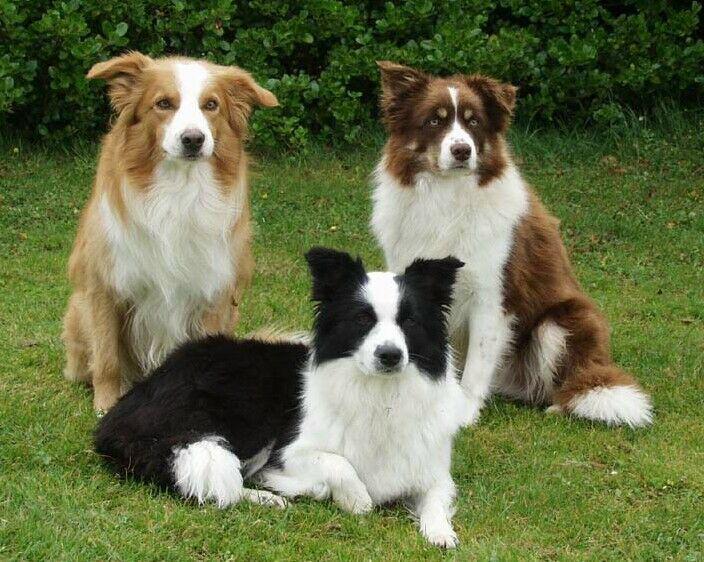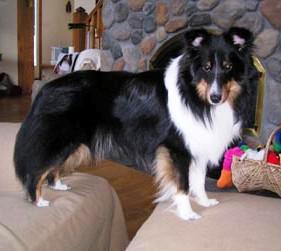The first image is the image on the left, the second image is the image on the right. Examine the images to the left and right. Is the description "An image shows a woman in black next to at least one collie dog." accurate? Answer yes or no. No. The first image is the image on the left, the second image is the image on the right. Given the left and right images, does the statement "One dog photo is taken outside in a grassy area, while the other is taken inside in a private home setting." hold true? Answer yes or no. Yes. 